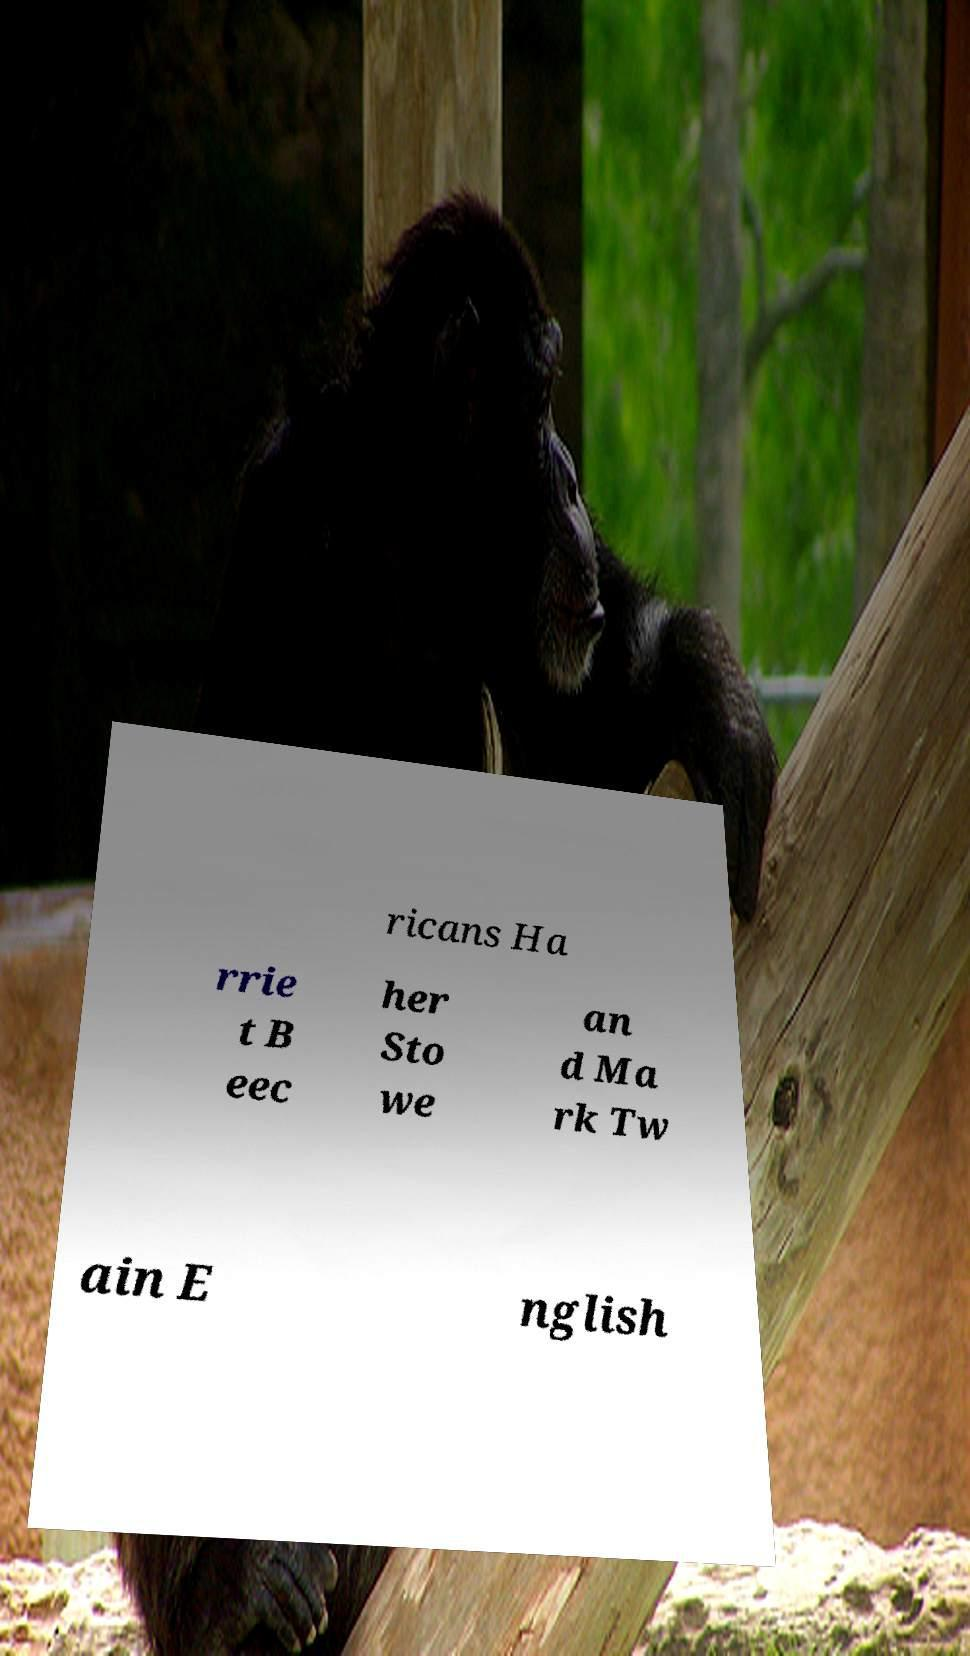Could you assist in decoding the text presented in this image and type it out clearly? ricans Ha rrie t B eec her Sto we an d Ma rk Tw ain E nglish 